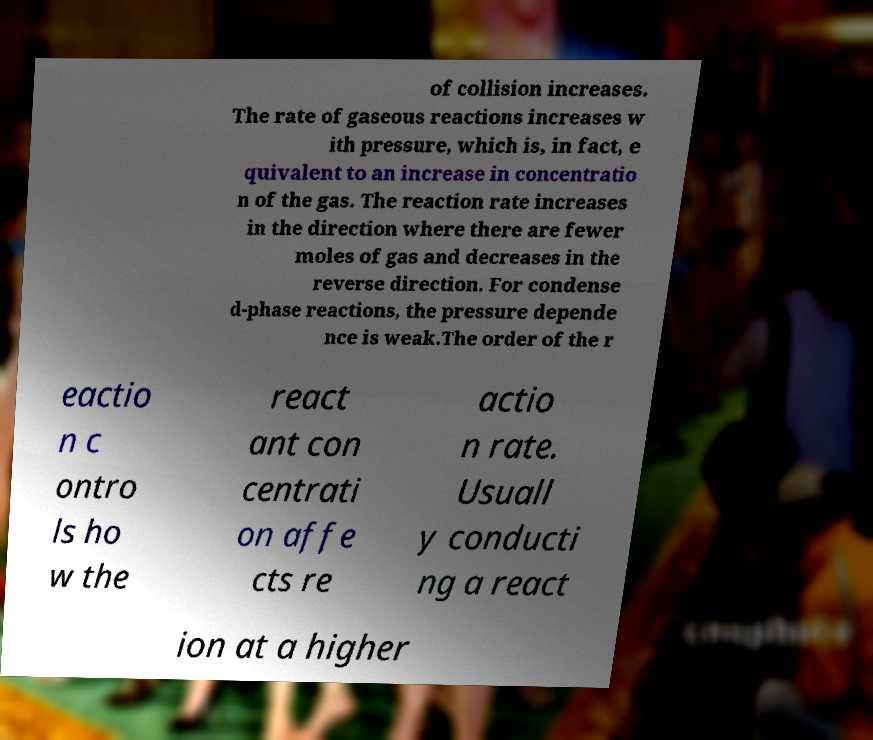Please identify and transcribe the text found in this image. of collision increases. The rate of gaseous reactions increases w ith pressure, which is, in fact, e quivalent to an increase in concentratio n of the gas. The reaction rate increases in the direction where there are fewer moles of gas and decreases in the reverse direction. For condense d-phase reactions, the pressure depende nce is weak.The order of the r eactio n c ontro ls ho w the react ant con centrati on affe cts re actio n rate. Usuall y conducti ng a react ion at a higher 